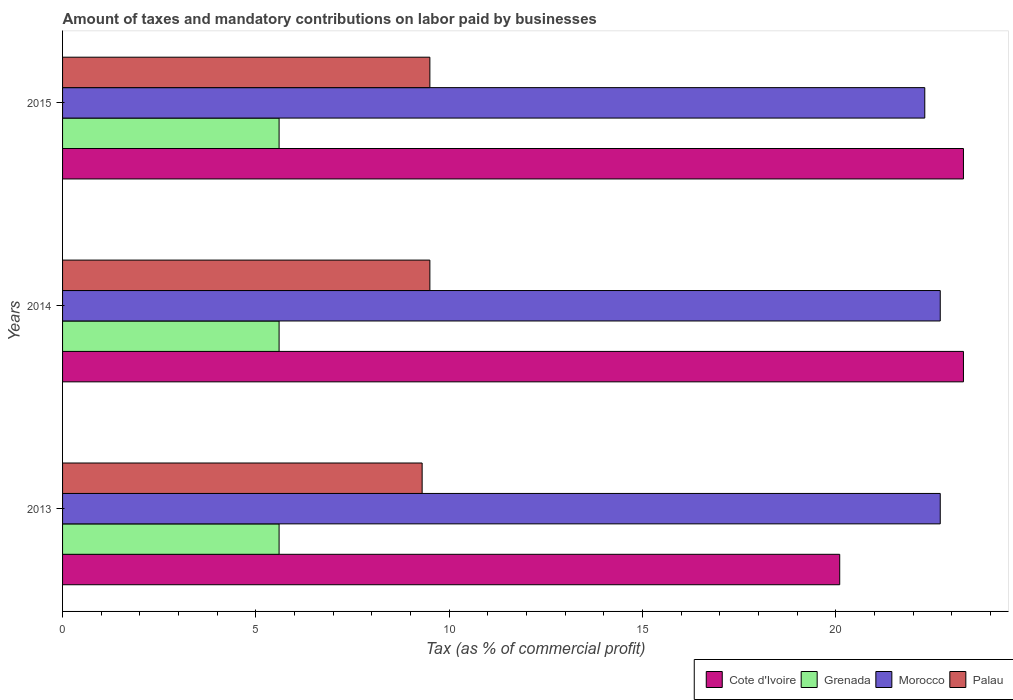How many different coloured bars are there?
Ensure brevity in your answer.  4. How many groups of bars are there?
Provide a short and direct response. 3. Are the number of bars per tick equal to the number of legend labels?
Ensure brevity in your answer.  Yes. How many bars are there on the 3rd tick from the top?
Provide a short and direct response. 4. In how many cases, is the number of bars for a given year not equal to the number of legend labels?
Give a very brief answer. 0. What is the percentage of taxes paid by businesses in Palau in 2014?
Offer a terse response. 9.5. Across all years, what is the maximum percentage of taxes paid by businesses in Morocco?
Offer a very short reply. 22.7. What is the total percentage of taxes paid by businesses in Palau in the graph?
Keep it short and to the point. 28.3. What is the difference between the percentage of taxes paid by businesses in Grenada in 2013 and that in 2015?
Offer a very short reply. 0. What is the average percentage of taxes paid by businesses in Morocco per year?
Ensure brevity in your answer.  22.57. In the year 2014, what is the difference between the percentage of taxes paid by businesses in Cote d'Ivoire and percentage of taxes paid by businesses in Grenada?
Provide a succinct answer. 17.7. What is the ratio of the percentage of taxes paid by businesses in Cote d'Ivoire in 2013 to that in 2014?
Make the answer very short. 0.86. Is the difference between the percentage of taxes paid by businesses in Cote d'Ivoire in 2013 and 2015 greater than the difference between the percentage of taxes paid by businesses in Grenada in 2013 and 2015?
Offer a very short reply. No. What is the difference between the highest and the second highest percentage of taxes paid by businesses in Cote d'Ivoire?
Offer a terse response. 0. What is the difference between the highest and the lowest percentage of taxes paid by businesses in Grenada?
Your answer should be very brief. 0. Is the sum of the percentage of taxes paid by businesses in Morocco in 2014 and 2015 greater than the maximum percentage of taxes paid by businesses in Grenada across all years?
Provide a short and direct response. Yes. Is it the case that in every year, the sum of the percentage of taxes paid by businesses in Grenada and percentage of taxes paid by businesses in Palau is greater than the sum of percentage of taxes paid by businesses in Cote d'Ivoire and percentage of taxes paid by businesses in Morocco?
Provide a succinct answer. Yes. What does the 2nd bar from the top in 2015 represents?
Provide a short and direct response. Morocco. What does the 2nd bar from the bottom in 2014 represents?
Give a very brief answer. Grenada. Are all the bars in the graph horizontal?
Offer a very short reply. Yes. What is the difference between two consecutive major ticks on the X-axis?
Offer a very short reply. 5. Are the values on the major ticks of X-axis written in scientific E-notation?
Offer a terse response. No. Does the graph contain grids?
Give a very brief answer. No. How are the legend labels stacked?
Provide a succinct answer. Horizontal. What is the title of the graph?
Ensure brevity in your answer.  Amount of taxes and mandatory contributions on labor paid by businesses. What is the label or title of the X-axis?
Your answer should be compact. Tax (as % of commercial profit). What is the Tax (as % of commercial profit) of Cote d'Ivoire in 2013?
Ensure brevity in your answer.  20.1. What is the Tax (as % of commercial profit) in Grenada in 2013?
Offer a very short reply. 5.6. What is the Tax (as % of commercial profit) in Morocco in 2013?
Provide a short and direct response. 22.7. What is the Tax (as % of commercial profit) in Cote d'Ivoire in 2014?
Your response must be concise. 23.3. What is the Tax (as % of commercial profit) in Grenada in 2014?
Keep it short and to the point. 5.6. What is the Tax (as % of commercial profit) in Morocco in 2014?
Provide a succinct answer. 22.7. What is the Tax (as % of commercial profit) in Cote d'Ivoire in 2015?
Offer a very short reply. 23.3. What is the Tax (as % of commercial profit) of Morocco in 2015?
Offer a terse response. 22.3. What is the Tax (as % of commercial profit) of Palau in 2015?
Provide a succinct answer. 9.5. Across all years, what is the maximum Tax (as % of commercial profit) of Cote d'Ivoire?
Keep it short and to the point. 23.3. Across all years, what is the maximum Tax (as % of commercial profit) in Grenada?
Give a very brief answer. 5.6. Across all years, what is the maximum Tax (as % of commercial profit) of Morocco?
Provide a succinct answer. 22.7. Across all years, what is the maximum Tax (as % of commercial profit) of Palau?
Ensure brevity in your answer.  9.5. Across all years, what is the minimum Tax (as % of commercial profit) of Cote d'Ivoire?
Offer a terse response. 20.1. Across all years, what is the minimum Tax (as % of commercial profit) of Morocco?
Offer a terse response. 22.3. Across all years, what is the minimum Tax (as % of commercial profit) of Palau?
Offer a very short reply. 9.3. What is the total Tax (as % of commercial profit) in Cote d'Ivoire in the graph?
Make the answer very short. 66.7. What is the total Tax (as % of commercial profit) of Grenada in the graph?
Your answer should be compact. 16.8. What is the total Tax (as % of commercial profit) in Morocco in the graph?
Provide a succinct answer. 67.7. What is the total Tax (as % of commercial profit) in Palau in the graph?
Offer a very short reply. 28.3. What is the difference between the Tax (as % of commercial profit) in Cote d'Ivoire in 2013 and that in 2014?
Provide a succinct answer. -3.2. What is the difference between the Tax (as % of commercial profit) of Grenada in 2013 and that in 2014?
Give a very brief answer. 0. What is the difference between the Tax (as % of commercial profit) in Grenada in 2013 and that in 2015?
Give a very brief answer. 0. What is the difference between the Tax (as % of commercial profit) in Palau in 2013 and that in 2015?
Offer a terse response. -0.2. What is the difference between the Tax (as % of commercial profit) in Cote d'Ivoire in 2014 and that in 2015?
Ensure brevity in your answer.  0. What is the difference between the Tax (as % of commercial profit) in Grenada in 2013 and the Tax (as % of commercial profit) in Morocco in 2014?
Make the answer very short. -17.1. What is the difference between the Tax (as % of commercial profit) in Grenada in 2013 and the Tax (as % of commercial profit) in Palau in 2014?
Provide a short and direct response. -3.9. What is the difference between the Tax (as % of commercial profit) in Morocco in 2013 and the Tax (as % of commercial profit) in Palau in 2014?
Give a very brief answer. 13.2. What is the difference between the Tax (as % of commercial profit) of Cote d'Ivoire in 2013 and the Tax (as % of commercial profit) of Grenada in 2015?
Offer a terse response. 14.5. What is the difference between the Tax (as % of commercial profit) in Cote d'Ivoire in 2013 and the Tax (as % of commercial profit) in Morocco in 2015?
Give a very brief answer. -2.2. What is the difference between the Tax (as % of commercial profit) in Cote d'Ivoire in 2013 and the Tax (as % of commercial profit) in Palau in 2015?
Offer a very short reply. 10.6. What is the difference between the Tax (as % of commercial profit) in Grenada in 2013 and the Tax (as % of commercial profit) in Morocco in 2015?
Your answer should be very brief. -16.7. What is the difference between the Tax (as % of commercial profit) in Cote d'Ivoire in 2014 and the Tax (as % of commercial profit) in Grenada in 2015?
Ensure brevity in your answer.  17.7. What is the difference between the Tax (as % of commercial profit) in Cote d'Ivoire in 2014 and the Tax (as % of commercial profit) in Morocco in 2015?
Make the answer very short. 1. What is the difference between the Tax (as % of commercial profit) in Cote d'Ivoire in 2014 and the Tax (as % of commercial profit) in Palau in 2015?
Offer a very short reply. 13.8. What is the difference between the Tax (as % of commercial profit) of Grenada in 2014 and the Tax (as % of commercial profit) of Morocco in 2015?
Keep it short and to the point. -16.7. What is the difference between the Tax (as % of commercial profit) of Grenada in 2014 and the Tax (as % of commercial profit) of Palau in 2015?
Your answer should be compact. -3.9. What is the average Tax (as % of commercial profit) in Cote d'Ivoire per year?
Offer a very short reply. 22.23. What is the average Tax (as % of commercial profit) in Morocco per year?
Give a very brief answer. 22.57. What is the average Tax (as % of commercial profit) in Palau per year?
Give a very brief answer. 9.43. In the year 2013, what is the difference between the Tax (as % of commercial profit) in Grenada and Tax (as % of commercial profit) in Morocco?
Offer a very short reply. -17.1. In the year 2013, what is the difference between the Tax (as % of commercial profit) in Grenada and Tax (as % of commercial profit) in Palau?
Make the answer very short. -3.7. In the year 2013, what is the difference between the Tax (as % of commercial profit) in Morocco and Tax (as % of commercial profit) in Palau?
Keep it short and to the point. 13.4. In the year 2014, what is the difference between the Tax (as % of commercial profit) in Cote d'Ivoire and Tax (as % of commercial profit) in Palau?
Provide a short and direct response. 13.8. In the year 2014, what is the difference between the Tax (as % of commercial profit) of Grenada and Tax (as % of commercial profit) of Morocco?
Ensure brevity in your answer.  -17.1. In the year 2014, what is the difference between the Tax (as % of commercial profit) in Morocco and Tax (as % of commercial profit) in Palau?
Provide a short and direct response. 13.2. In the year 2015, what is the difference between the Tax (as % of commercial profit) in Grenada and Tax (as % of commercial profit) in Morocco?
Your answer should be very brief. -16.7. What is the ratio of the Tax (as % of commercial profit) in Cote d'Ivoire in 2013 to that in 2014?
Offer a very short reply. 0.86. What is the ratio of the Tax (as % of commercial profit) of Grenada in 2013 to that in 2014?
Your answer should be compact. 1. What is the ratio of the Tax (as % of commercial profit) of Palau in 2013 to that in 2014?
Offer a terse response. 0.98. What is the ratio of the Tax (as % of commercial profit) of Cote d'Ivoire in 2013 to that in 2015?
Your response must be concise. 0.86. What is the ratio of the Tax (as % of commercial profit) in Grenada in 2013 to that in 2015?
Ensure brevity in your answer.  1. What is the ratio of the Tax (as % of commercial profit) of Morocco in 2013 to that in 2015?
Offer a very short reply. 1.02. What is the ratio of the Tax (as % of commercial profit) in Palau in 2013 to that in 2015?
Your answer should be compact. 0.98. What is the ratio of the Tax (as % of commercial profit) in Grenada in 2014 to that in 2015?
Provide a short and direct response. 1. What is the ratio of the Tax (as % of commercial profit) in Morocco in 2014 to that in 2015?
Provide a short and direct response. 1.02. What is the ratio of the Tax (as % of commercial profit) in Palau in 2014 to that in 2015?
Ensure brevity in your answer.  1. What is the difference between the highest and the second highest Tax (as % of commercial profit) in Cote d'Ivoire?
Provide a succinct answer. 0. What is the difference between the highest and the lowest Tax (as % of commercial profit) in Cote d'Ivoire?
Your answer should be compact. 3.2. What is the difference between the highest and the lowest Tax (as % of commercial profit) in Grenada?
Give a very brief answer. 0. 